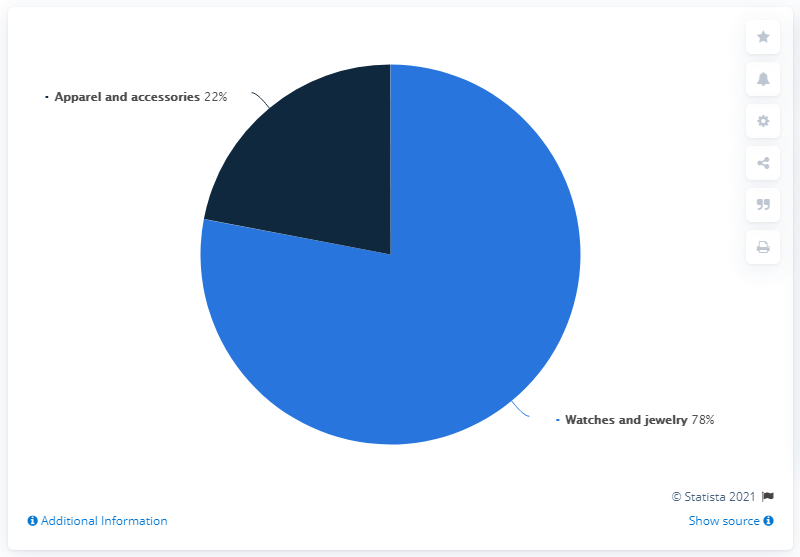Highlight a few significant elements in this photo. In 2019, used watches and jewelry accounted for approximately 78% of the second-hand personal luxury goods market. The ratio between apparel and accessories and watches and jewelry is 0.282051282051282051282051282051282051282051282051282051282051282051282. It is possible to determine the percentage of watches and jewelry in a dataset. 